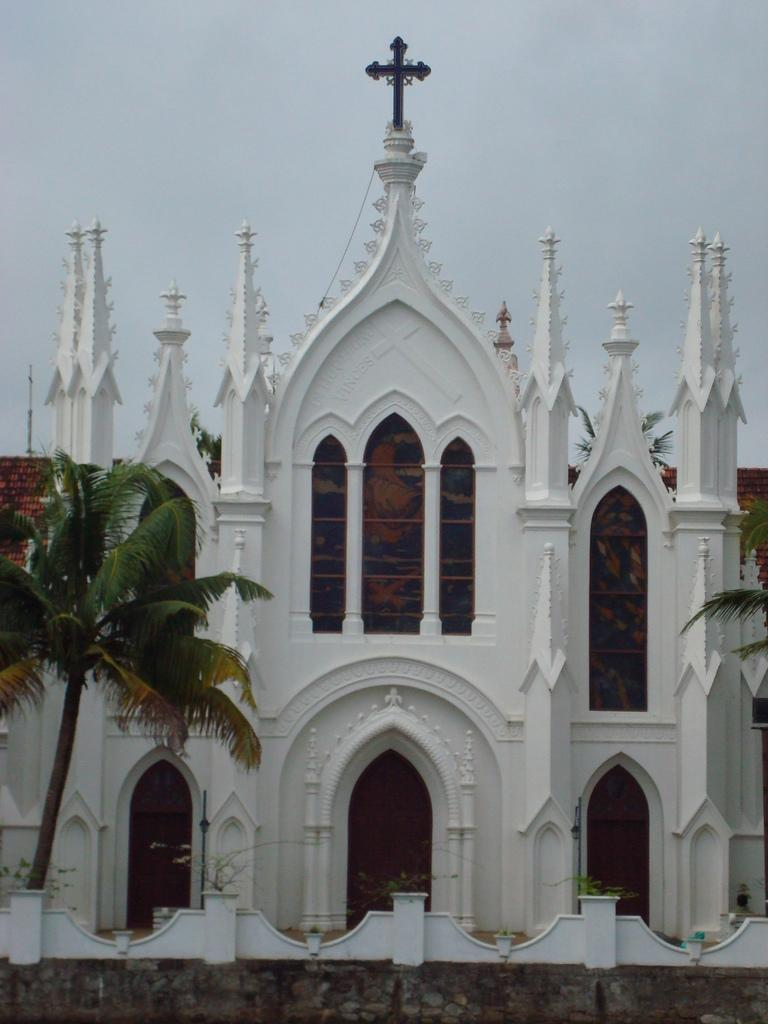What type of building is in the image? There is a church in the image. What is at the top of the church? There is a cross symbol at the top of the church. What can be seen in front of the church? There are plants and trees in front of the church. What is visible in the background of the image? The sky is visible in the background of the image. How many people are walking in the carriage in the image? There is no carriage or people walking in the image; it features a church with a cross symbol, plants and trees, and a visible sky. 